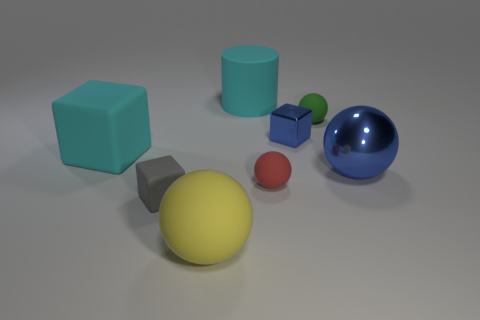What color is the cylinder that is made of the same material as the red sphere? cyan 